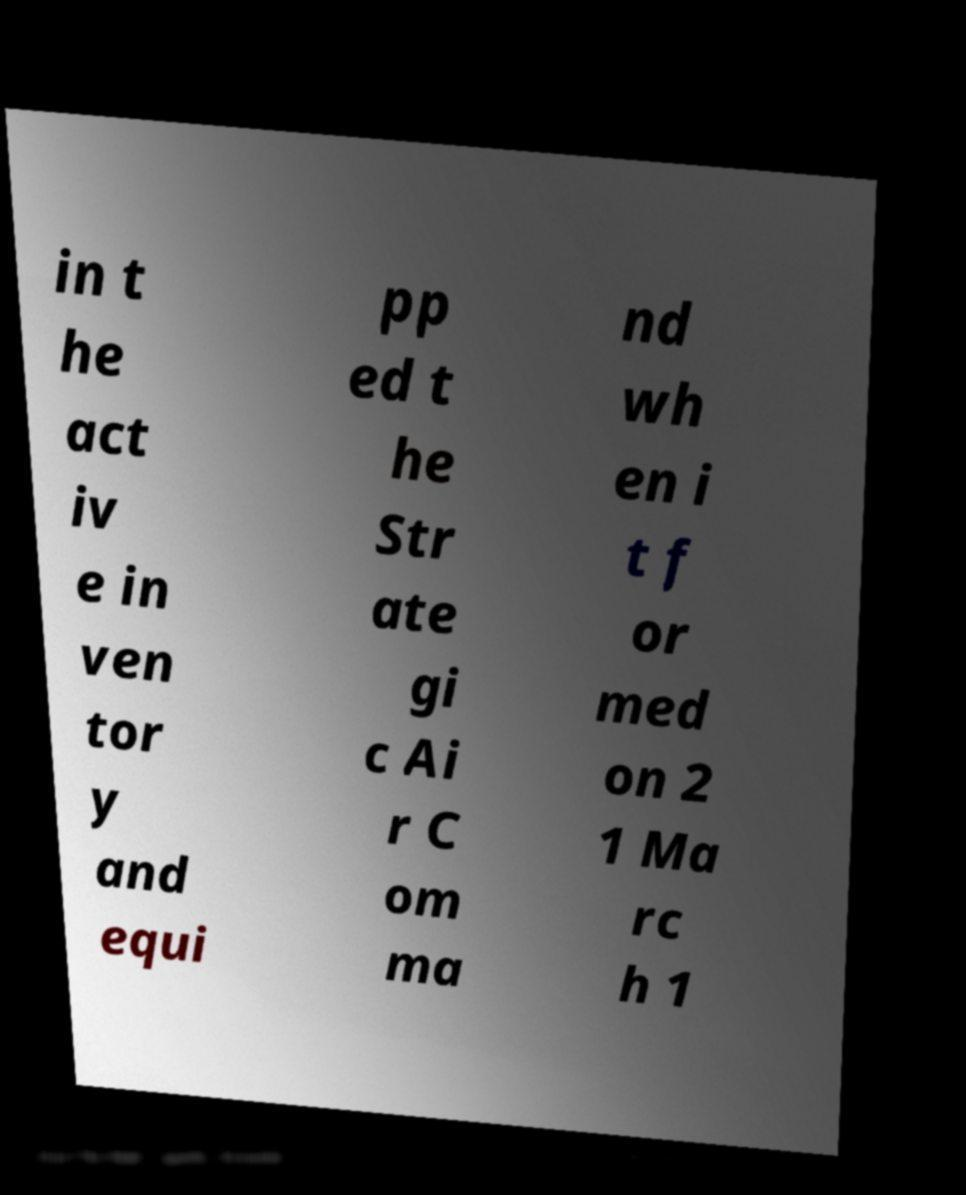I need the written content from this picture converted into text. Can you do that? in t he act iv e in ven tor y and equi pp ed t he Str ate gi c Ai r C om ma nd wh en i t f or med on 2 1 Ma rc h 1 